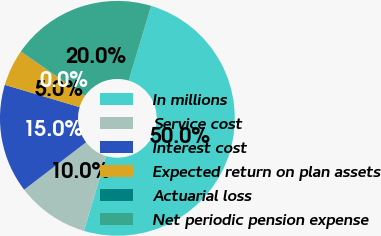Convert chart to OTSL. <chart><loc_0><loc_0><loc_500><loc_500><pie_chart><fcel>In millions<fcel>Service cost<fcel>Interest cost<fcel>Expected return on plan assets<fcel>Actuarial loss<fcel>Net periodic pension expense<nl><fcel>49.95%<fcel>10.01%<fcel>15.0%<fcel>5.02%<fcel>0.02%<fcel>20.0%<nl></chart> 